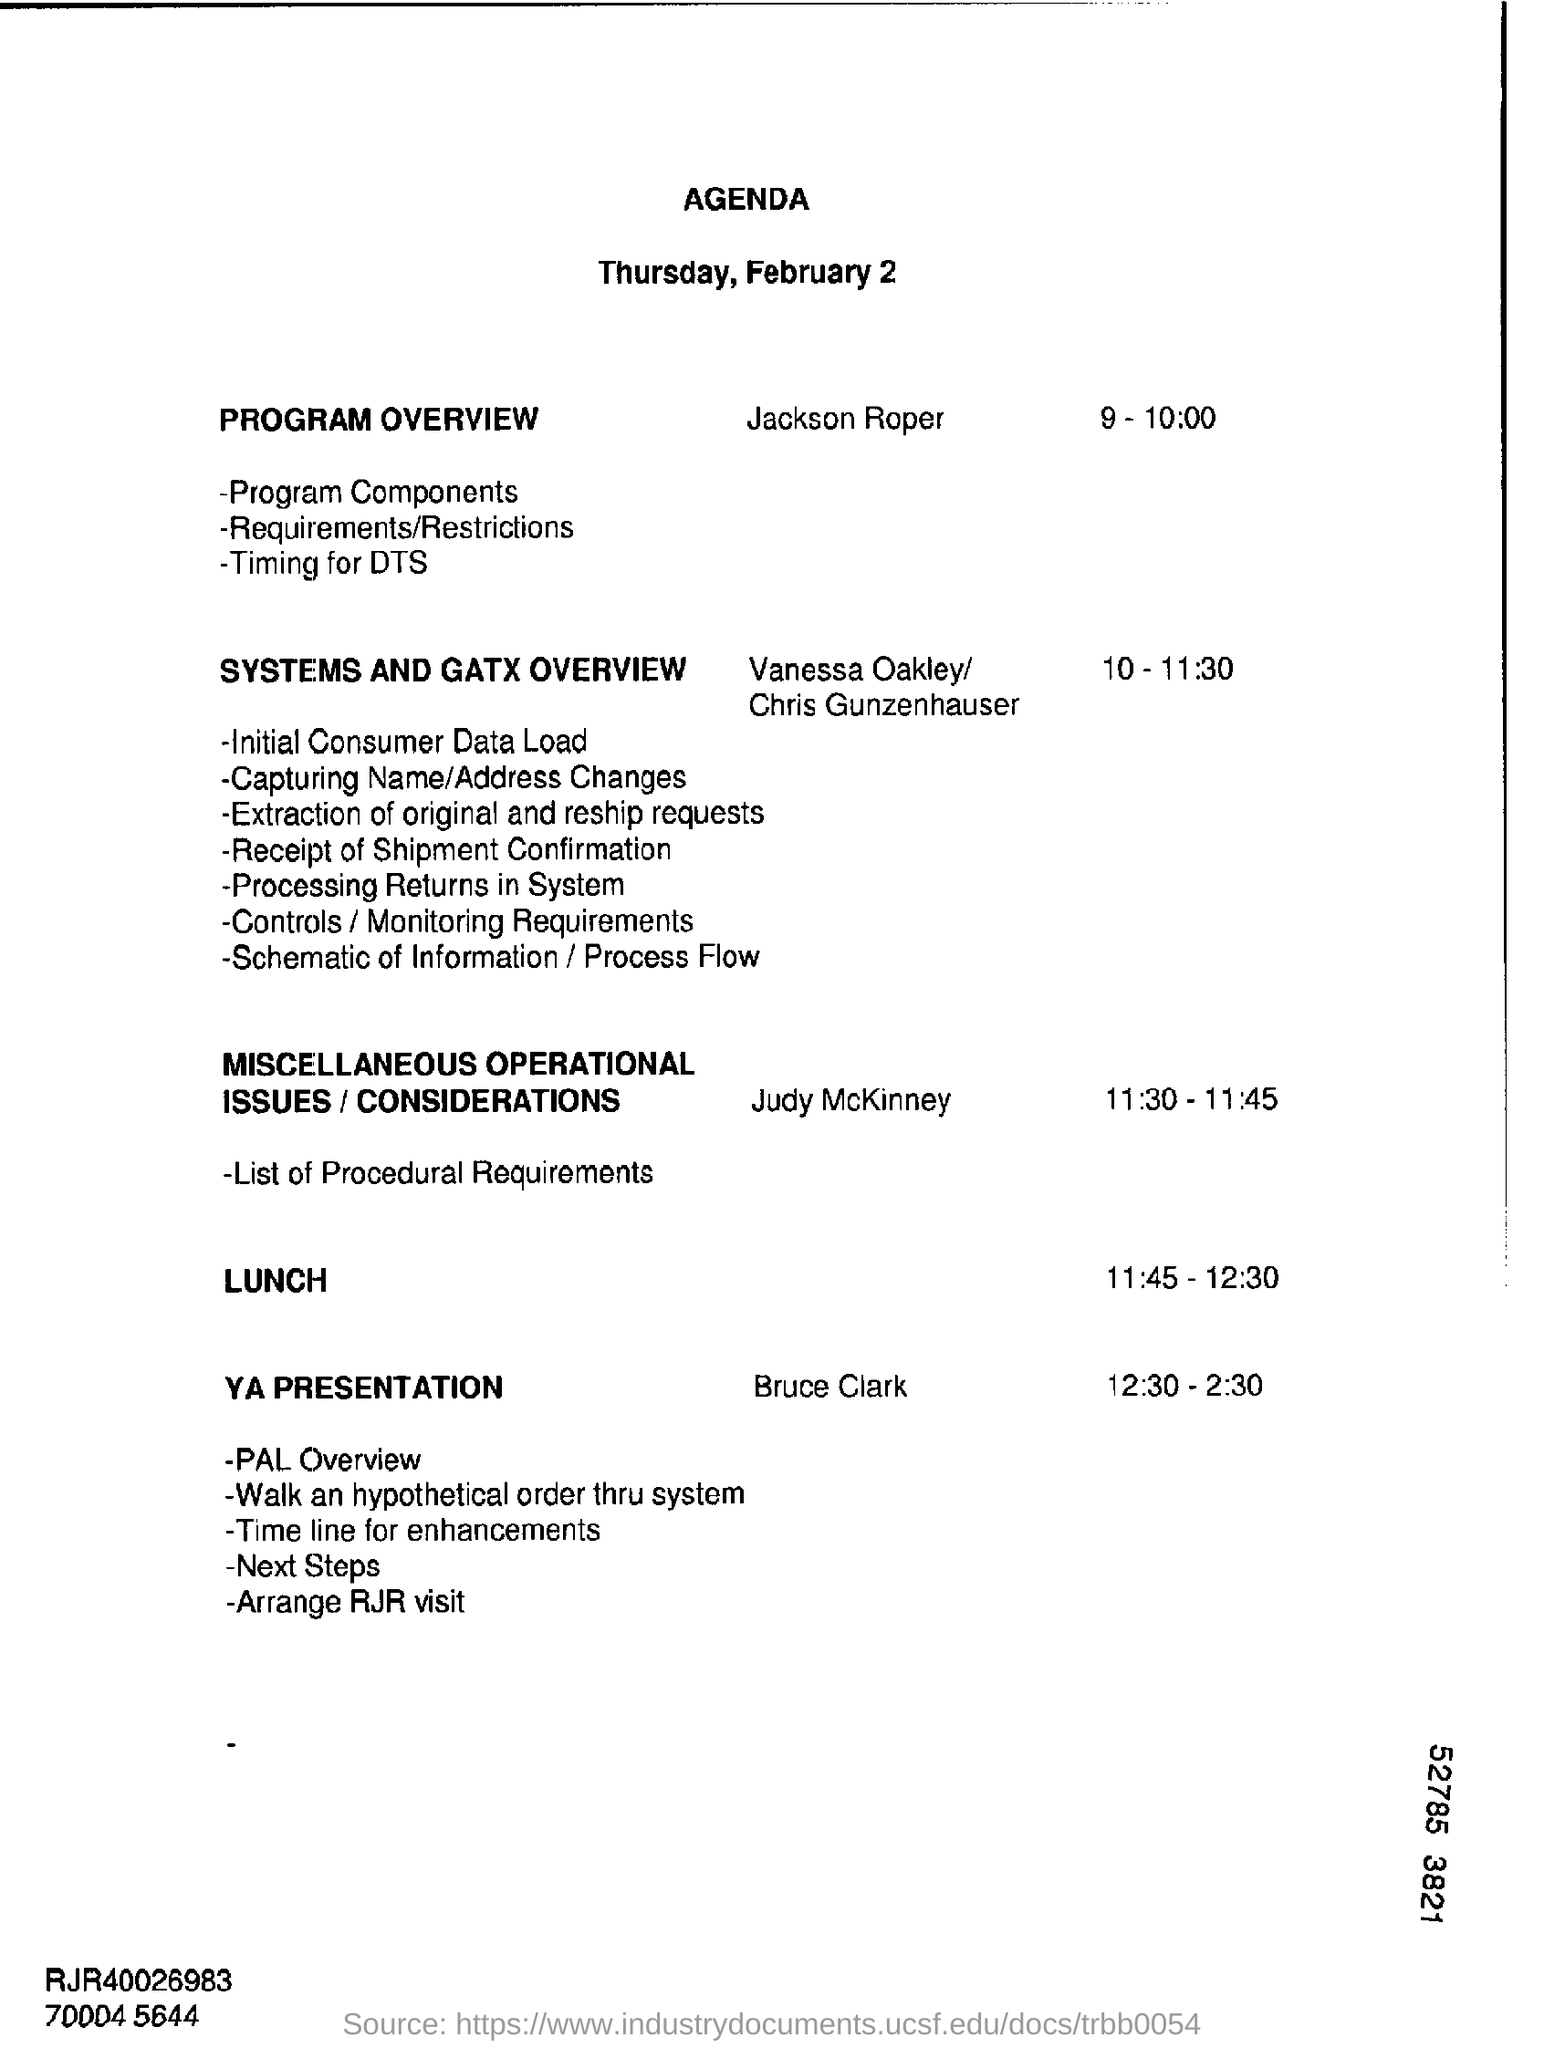What is the timing for YA PRESENTATION by Bruce Clark?
Give a very brief answer. 12:30 - 2:30. When is the PROGRAM OVERVIEW scheduled to?
Provide a succinct answer. 9 - 10:00. 